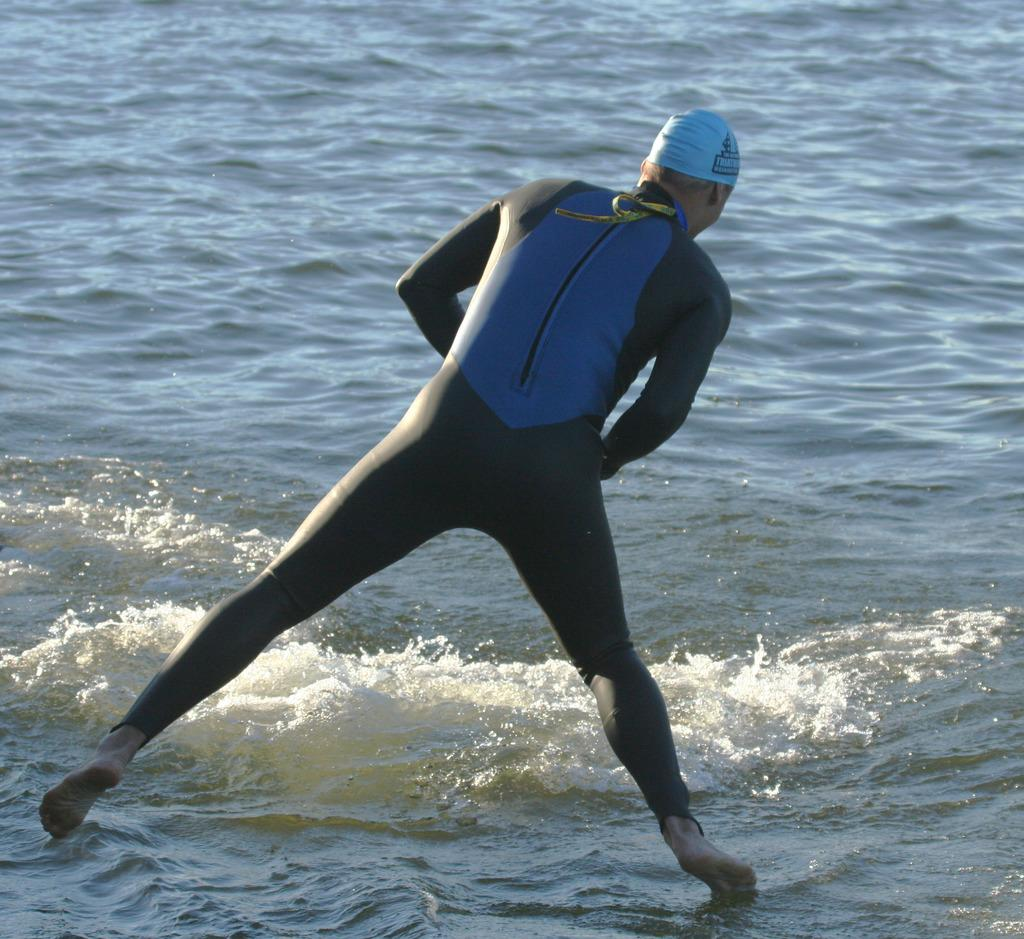What is happening in the image? There is a person in the image, and they are jumping into the sea. What can be inferred about the person's clothing? The person is wearing a dress with black and blue colors. What is the person's annual income in the image? There is no information about the person's income in the image. What type of operation is being performed on the person in the image? There is no indication of any operation being performed on the person in the image; the person is simply jumping into the sea. 